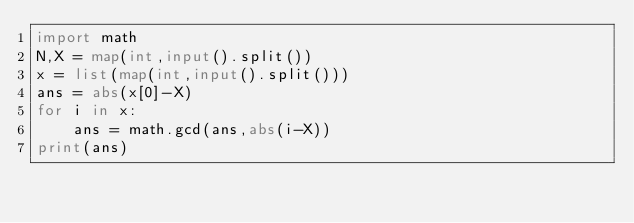Convert code to text. <code><loc_0><loc_0><loc_500><loc_500><_Python_>import math
N,X = map(int,input().split())
x = list(map(int,input().split()))
ans = abs(x[0]-X)
for i in x:
    ans = math.gcd(ans,abs(i-X))
print(ans)</code> 